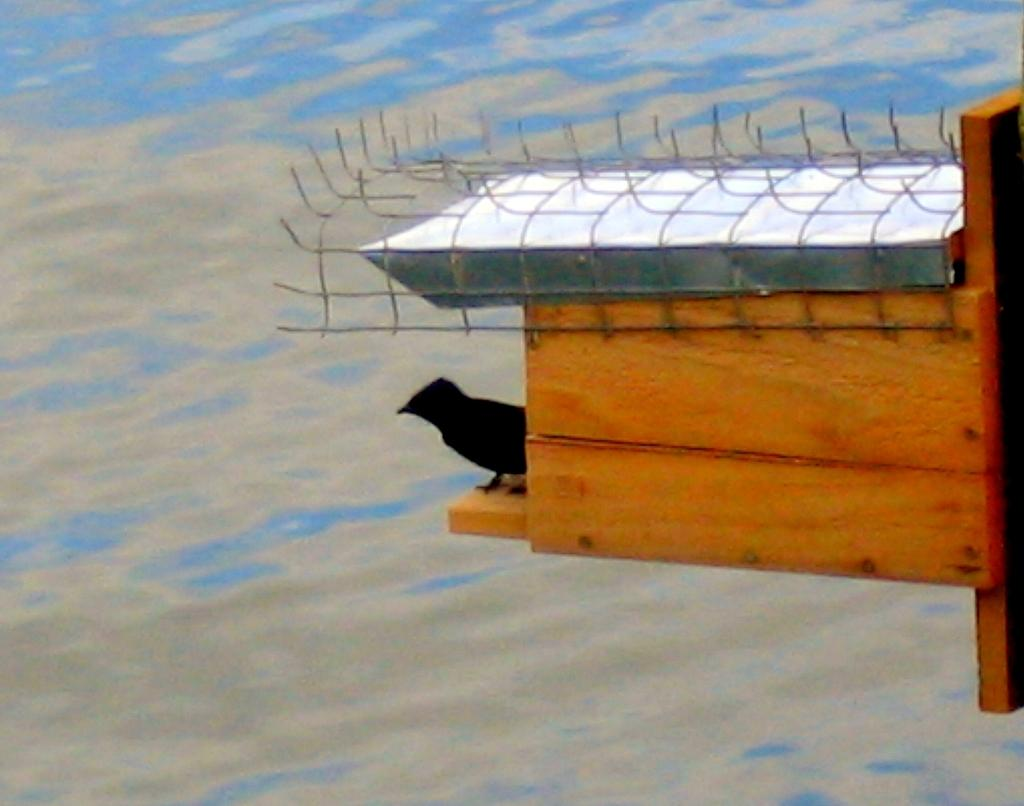Where was the picture taken? The picture was clicked outside the city. What can be seen on the right side of the image? There is a wooden object on the right side of the image. What is on the wooden object? A bird is standing on the wooden object. What color is the object in the background of the image? There is a blue color object in the background of the image. What impulse did the bird have to stand on the wooden object? There is no information about the bird's impulse in the image, so we cannot determine why the bird is standing on the wooden object. 